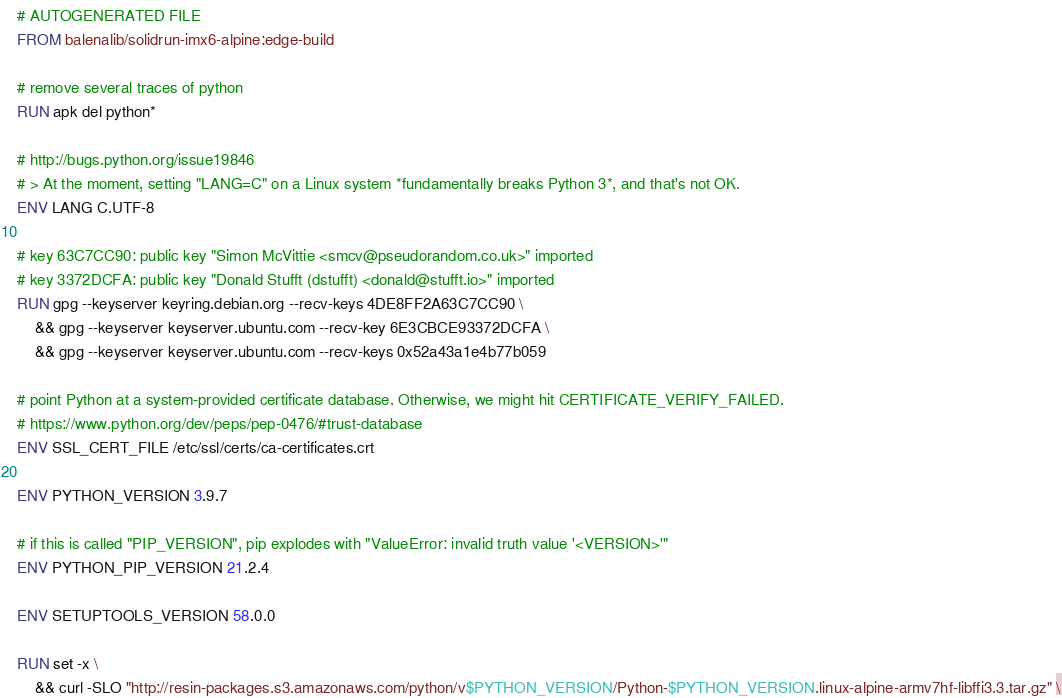<code> <loc_0><loc_0><loc_500><loc_500><_Dockerfile_># AUTOGENERATED FILE
FROM balenalib/solidrun-imx6-alpine:edge-build

# remove several traces of python
RUN apk del python*

# http://bugs.python.org/issue19846
# > At the moment, setting "LANG=C" on a Linux system *fundamentally breaks Python 3*, and that's not OK.
ENV LANG C.UTF-8

# key 63C7CC90: public key "Simon McVittie <smcv@pseudorandom.co.uk>" imported
# key 3372DCFA: public key "Donald Stufft (dstufft) <donald@stufft.io>" imported
RUN gpg --keyserver keyring.debian.org --recv-keys 4DE8FF2A63C7CC90 \
	&& gpg --keyserver keyserver.ubuntu.com --recv-key 6E3CBCE93372DCFA \
	&& gpg --keyserver keyserver.ubuntu.com --recv-keys 0x52a43a1e4b77b059

# point Python at a system-provided certificate database. Otherwise, we might hit CERTIFICATE_VERIFY_FAILED.
# https://www.python.org/dev/peps/pep-0476/#trust-database
ENV SSL_CERT_FILE /etc/ssl/certs/ca-certificates.crt

ENV PYTHON_VERSION 3.9.7

# if this is called "PIP_VERSION", pip explodes with "ValueError: invalid truth value '<VERSION>'"
ENV PYTHON_PIP_VERSION 21.2.4

ENV SETUPTOOLS_VERSION 58.0.0

RUN set -x \
	&& curl -SLO "http://resin-packages.s3.amazonaws.com/python/v$PYTHON_VERSION/Python-$PYTHON_VERSION.linux-alpine-armv7hf-libffi3.3.tar.gz" \</code> 